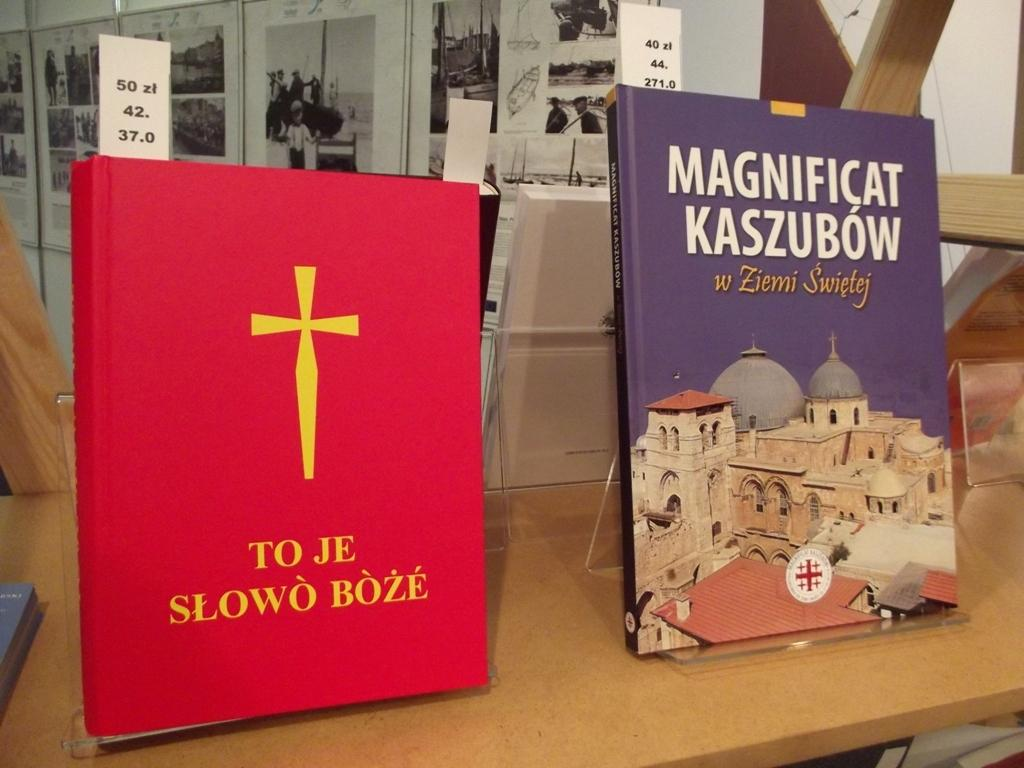<image>
Render a clear and concise summary of the photo. Two books are displayed side by side, the one on the left titled "To Je Slowo Boze". 